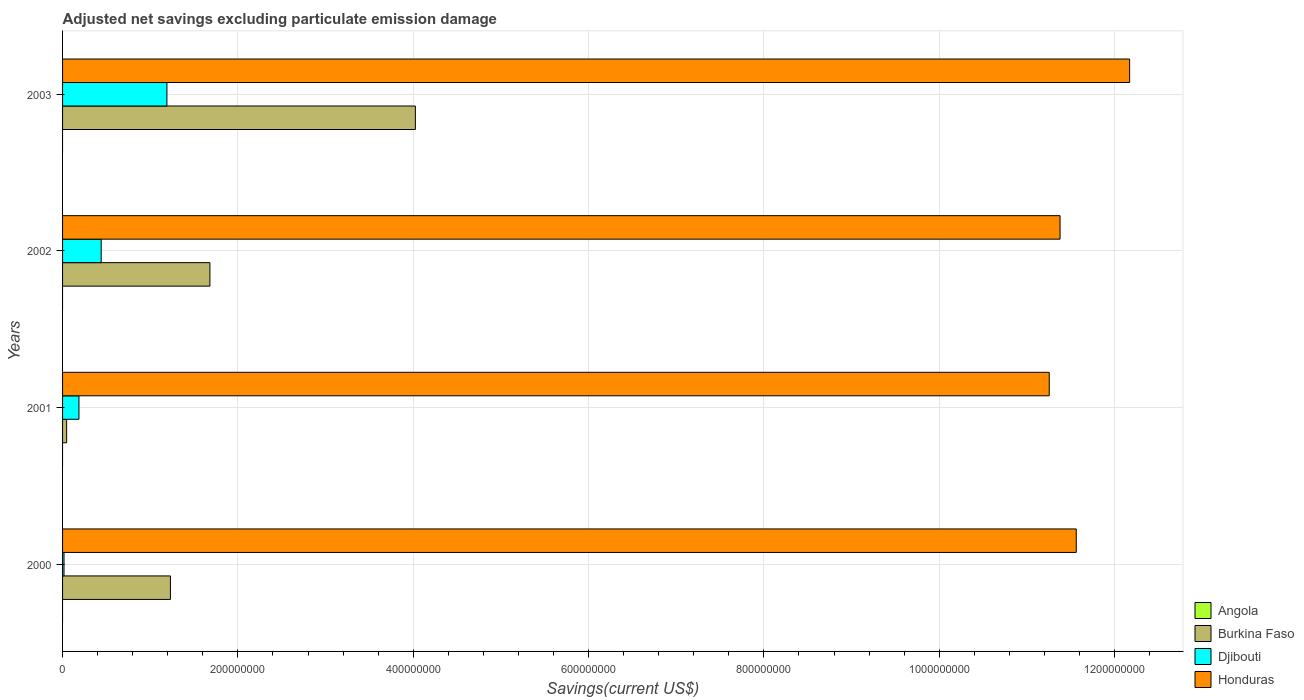How many bars are there on the 1st tick from the bottom?
Ensure brevity in your answer.  3. In how many cases, is the number of bars for a given year not equal to the number of legend labels?
Ensure brevity in your answer.  4. What is the adjusted net savings in Honduras in 2001?
Your answer should be very brief. 1.13e+09. Across all years, what is the maximum adjusted net savings in Burkina Faso?
Your answer should be compact. 4.02e+08. Across all years, what is the minimum adjusted net savings in Angola?
Provide a short and direct response. 0. In which year was the adjusted net savings in Burkina Faso maximum?
Offer a terse response. 2003. What is the total adjusted net savings in Honduras in the graph?
Give a very brief answer. 4.64e+09. What is the difference between the adjusted net savings in Honduras in 2000 and that in 2002?
Offer a terse response. 1.85e+07. What is the difference between the adjusted net savings in Angola in 2001 and the adjusted net savings in Djibouti in 2003?
Give a very brief answer. -1.19e+08. What is the average adjusted net savings in Burkina Faso per year?
Your answer should be compact. 1.75e+08. In the year 2000, what is the difference between the adjusted net savings in Burkina Faso and adjusted net savings in Djibouti?
Keep it short and to the point. 1.21e+08. What is the ratio of the adjusted net savings in Honduras in 2000 to that in 2003?
Give a very brief answer. 0.95. What is the difference between the highest and the second highest adjusted net savings in Djibouti?
Your answer should be very brief. 7.50e+07. What is the difference between the highest and the lowest adjusted net savings in Burkina Faso?
Your answer should be very brief. 3.98e+08. Is it the case that in every year, the sum of the adjusted net savings in Burkina Faso and adjusted net savings in Honduras is greater than the sum of adjusted net savings in Angola and adjusted net savings in Djibouti?
Provide a succinct answer. Yes. Is it the case that in every year, the sum of the adjusted net savings in Djibouti and adjusted net savings in Angola is greater than the adjusted net savings in Honduras?
Offer a very short reply. No. How many bars are there?
Keep it short and to the point. 12. Does the graph contain any zero values?
Offer a terse response. Yes. How many legend labels are there?
Provide a succinct answer. 4. How are the legend labels stacked?
Keep it short and to the point. Vertical. What is the title of the graph?
Offer a terse response. Adjusted net savings excluding particulate emission damage. Does "Swaziland" appear as one of the legend labels in the graph?
Keep it short and to the point. No. What is the label or title of the X-axis?
Offer a very short reply. Savings(current US$). What is the label or title of the Y-axis?
Provide a succinct answer. Years. What is the Savings(current US$) of Burkina Faso in 2000?
Provide a short and direct response. 1.23e+08. What is the Savings(current US$) of Djibouti in 2000?
Give a very brief answer. 1.66e+06. What is the Savings(current US$) of Honduras in 2000?
Provide a succinct answer. 1.16e+09. What is the Savings(current US$) in Burkina Faso in 2001?
Your answer should be very brief. 4.64e+06. What is the Savings(current US$) in Djibouti in 2001?
Provide a short and direct response. 1.87e+07. What is the Savings(current US$) in Honduras in 2001?
Ensure brevity in your answer.  1.13e+09. What is the Savings(current US$) in Burkina Faso in 2002?
Your answer should be very brief. 1.68e+08. What is the Savings(current US$) in Djibouti in 2002?
Give a very brief answer. 4.41e+07. What is the Savings(current US$) of Honduras in 2002?
Your answer should be very brief. 1.14e+09. What is the Savings(current US$) of Burkina Faso in 2003?
Keep it short and to the point. 4.02e+08. What is the Savings(current US$) in Djibouti in 2003?
Your answer should be compact. 1.19e+08. What is the Savings(current US$) in Honduras in 2003?
Ensure brevity in your answer.  1.22e+09. Across all years, what is the maximum Savings(current US$) of Burkina Faso?
Your response must be concise. 4.02e+08. Across all years, what is the maximum Savings(current US$) of Djibouti?
Make the answer very short. 1.19e+08. Across all years, what is the maximum Savings(current US$) in Honduras?
Offer a very short reply. 1.22e+09. Across all years, what is the minimum Savings(current US$) in Burkina Faso?
Provide a short and direct response. 4.64e+06. Across all years, what is the minimum Savings(current US$) in Djibouti?
Provide a short and direct response. 1.66e+06. Across all years, what is the minimum Savings(current US$) of Honduras?
Offer a very short reply. 1.13e+09. What is the total Savings(current US$) in Burkina Faso in the graph?
Offer a terse response. 6.98e+08. What is the total Savings(current US$) of Djibouti in the graph?
Your answer should be compact. 1.83e+08. What is the total Savings(current US$) of Honduras in the graph?
Your answer should be compact. 4.64e+09. What is the difference between the Savings(current US$) of Burkina Faso in 2000 and that in 2001?
Offer a terse response. 1.18e+08. What is the difference between the Savings(current US$) in Djibouti in 2000 and that in 2001?
Give a very brief answer. -1.70e+07. What is the difference between the Savings(current US$) in Honduras in 2000 and that in 2001?
Give a very brief answer. 3.08e+07. What is the difference between the Savings(current US$) of Burkina Faso in 2000 and that in 2002?
Your response must be concise. -4.50e+07. What is the difference between the Savings(current US$) in Djibouti in 2000 and that in 2002?
Your answer should be very brief. -4.24e+07. What is the difference between the Savings(current US$) of Honduras in 2000 and that in 2002?
Provide a short and direct response. 1.85e+07. What is the difference between the Savings(current US$) of Burkina Faso in 2000 and that in 2003?
Your response must be concise. -2.79e+08. What is the difference between the Savings(current US$) of Djibouti in 2000 and that in 2003?
Offer a terse response. -1.17e+08. What is the difference between the Savings(current US$) in Honduras in 2000 and that in 2003?
Provide a succinct answer. -6.09e+07. What is the difference between the Savings(current US$) in Burkina Faso in 2001 and that in 2002?
Provide a short and direct response. -1.63e+08. What is the difference between the Savings(current US$) of Djibouti in 2001 and that in 2002?
Keep it short and to the point. -2.54e+07. What is the difference between the Savings(current US$) in Honduras in 2001 and that in 2002?
Provide a short and direct response. -1.24e+07. What is the difference between the Savings(current US$) in Burkina Faso in 2001 and that in 2003?
Ensure brevity in your answer.  -3.98e+08. What is the difference between the Savings(current US$) in Djibouti in 2001 and that in 2003?
Provide a succinct answer. -1.00e+08. What is the difference between the Savings(current US$) of Honduras in 2001 and that in 2003?
Give a very brief answer. -9.17e+07. What is the difference between the Savings(current US$) in Burkina Faso in 2002 and that in 2003?
Offer a terse response. -2.34e+08. What is the difference between the Savings(current US$) in Djibouti in 2002 and that in 2003?
Give a very brief answer. -7.50e+07. What is the difference between the Savings(current US$) of Honduras in 2002 and that in 2003?
Offer a terse response. -7.94e+07. What is the difference between the Savings(current US$) in Burkina Faso in 2000 and the Savings(current US$) in Djibouti in 2001?
Ensure brevity in your answer.  1.04e+08. What is the difference between the Savings(current US$) of Burkina Faso in 2000 and the Savings(current US$) of Honduras in 2001?
Keep it short and to the point. -1.00e+09. What is the difference between the Savings(current US$) in Djibouti in 2000 and the Savings(current US$) in Honduras in 2001?
Provide a succinct answer. -1.12e+09. What is the difference between the Savings(current US$) in Burkina Faso in 2000 and the Savings(current US$) in Djibouti in 2002?
Your response must be concise. 7.90e+07. What is the difference between the Savings(current US$) in Burkina Faso in 2000 and the Savings(current US$) in Honduras in 2002?
Ensure brevity in your answer.  -1.01e+09. What is the difference between the Savings(current US$) of Djibouti in 2000 and the Savings(current US$) of Honduras in 2002?
Provide a succinct answer. -1.14e+09. What is the difference between the Savings(current US$) of Burkina Faso in 2000 and the Savings(current US$) of Djibouti in 2003?
Make the answer very short. 4.00e+06. What is the difference between the Savings(current US$) in Burkina Faso in 2000 and the Savings(current US$) in Honduras in 2003?
Offer a very short reply. -1.09e+09. What is the difference between the Savings(current US$) in Djibouti in 2000 and the Savings(current US$) in Honduras in 2003?
Make the answer very short. -1.22e+09. What is the difference between the Savings(current US$) of Burkina Faso in 2001 and the Savings(current US$) of Djibouti in 2002?
Offer a terse response. -3.94e+07. What is the difference between the Savings(current US$) of Burkina Faso in 2001 and the Savings(current US$) of Honduras in 2002?
Give a very brief answer. -1.13e+09. What is the difference between the Savings(current US$) in Djibouti in 2001 and the Savings(current US$) in Honduras in 2002?
Your answer should be very brief. -1.12e+09. What is the difference between the Savings(current US$) of Burkina Faso in 2001 and the Savings(current US$) of Djibouti in 2003?
Give a very brief answer. -1.14e+08. What is the difference between the Savings(current US$) in Burkina Faso in 2001 and the Savings(current US$) in Honduras in 2003?
Provide a succinct answer. -1.21e+09. What is the difference between the Savings(current US$) of Djibouti in 2001 and the Savings(current US$) of Honduras in 2003?
Offer a very short reply. -1.20e+09. What is the difference between the Savings(current US$) in Burkina Faso in 2002 and the Savings(current US$) in Djibouti in 2003?
Keep it short and to the point. 4.90e+07. What is the difference between the Savings(current US$) in Burkina Faso in 2002 and the Savings(current US$) in Honduras in 2003?
Provide a succinct answer. -1.05e+09. What is the difference between the Savings(current US$) of Djibouti in 2002 and the Savings(current US$) of Honduras in 2003?
Provide a succinct answer. -1.17e+09. What is the average Savings(current US$) of Angola per year?
Ensure brevity in your answer.  0. What is the average Savings(current US$) in Burkina Faso per year?
Make the answer very short. 1.75e+08. What is the average Savings(current US$) in Djibouti per year?
Provide a succinct answer. 4.59e+07. What is the average Savings(current US$) of Honduras per year?
Ensure brevity in your answer.  1.16e+09. In the year 2000, what is the difference between the Savings(current US$) of Burkina Faso and Savings(current US$) of Djibouti?
Keep it short and to the point. 1.21e+08. In the year 2000, what is the difference between the Savings(current US$) in Burkina Faso and Savings(current US$) in Honduras?
Ensure brevity in your answer.  -1.03e+09. In the year 2000, what is the difference between the Savings(current US$) of Djibouti and Savings(current US$) of Honduras?
Provide a short and direct response. -1.15e+09. In the year 2001, what is the difference between the Savings(current US$) in Burkina Faso and Savings(current US$) in Djibouti?
Ensure brevity in your answer.  -1.41e+07. In the year 2001, what is the difference between the Savings(current US$) of Burkina Faso and Savings(current US$) of Honduras?
Offer a very short reply. -1.12e+09. In the year 2001, what is the difference between the Savings(current US$) in Djibouti and Savings(current US$) in Honduras?
Ensure brevity in your answer.  -1.11e+09. In the year 2002, what is the difference between the Savings(current US$) of Burkina Faso and Savings(current US$) of Djibouti?
Ensure brevity in your answer.  1.24e+08. In the year 2002, what is the difference between the Savings(current US$) of Burkina Faso and Savings(current US$) of Honduras?
Your response must be concise. -9.70e+08. In the year 2002, what is the difference between the Savings(current US$) of Djibouti and Savings(current US$) of Honduras?
Offer a terse response. -1.09e+09. In the year 2003, what is the difference between the Savings(current US$) of Burkina Faso and Savings(current US$) of Djibouti?
Provide a succinct answer. 2.83e+08. In the year 2003, what is the difference between the Savings(current US$) of Burkina Faso and Savings(current US$) of Honduras?
Provide a succinct answer. -8.15e+08. In the year 2003, what is the difference between the Savings(current US$) of Djibouti and Savings(current US$) of Honduras?
Your answer should be very brief. -1.10e+09. What is the ratio of the Savings(current US$) of Burkina Faso in 2000 to that in 2001?
Your response must be concise. 26.49. What is the ratio of the Savings(current US$) in Djibouti in 2000 to that in 2001?
Your answer should be very brief. 0.09. What is the ratio of the Savings(current US$) in Honduras in 2000 to that in 2001?
Provide a short and direct response. 1.03. What is the ratio of the Savings(current US$) of Burkina Faso in 2000 to that in 2002?
Offer a terse response. 0.73. What is the ratio of the Savings(current US$) of Djibouti in 2000 to that in 2002?
Keep it short and to the point. 0.04. What is the ratio of the Savings(current US$) in Honduras in 2000 to that in 2002?
Offer a very short reply. 1.02. What is the ratio of the Savings(current US$) of Burkina Faso in 2000 to that in 2003?
Your answer should be compact. 0.31. What is the ratio of the Savings(current US$) of Djibouti in 2000 to that in 2003?
Your response must be concise. 0.01. What is the ratio of the Savings(current US$) of Burkina Faso in 2001 to that in 2002?
Your answer should be compact. 0.03. What is the ratio of the Savings(current US$) in Djibouti in 2001 to that in 2002?
Your answer should be compact. 0.42. What is the ratio of the Savings(current US$) in Honduras in 2001 to that in 2002?
Keep it short and to the point. 0.99. What is the ratio of the Savings(current US$) in Burkina Faso in 2001 to that in 2003?
Keep it short and to the point. 0.01. What is the ratio of the Savings(current US$) of Djibouti in 2001 to that in 2003?
Your answer should be compact. 0.16. What is the ratio of the Savings(current US$) in Honduras in 2001 to that in 2003?
Provide a succinct answer. 0.92. What is the ratio of the Savings(current US$) in Burkina Faso in 2002 to that in 2003?
Your answer should be very brief. 0.42. What is the ratio of the Savings(current US$) of Djibouti in 2002 to that in 2003?
Provide a succinct answer. 0.37. What is the ratio of the Savings(current US$) in Honduras in 2002 to that in 2003?
Offer a terse response. 0.93. What is the difference between the highest and the second highest Savings(current US$) of Burkina Faso?
Provide a succinct answer. 2.34e+08. What is the difference between the highest and the second highest Savings(current US$) of Djibouti?
Your answer should be compact. 7.50e+07. What is the difference between the highest and the second highest Savings(current US$) in Honduras?
Make the answer very short. 6.09e+07. What is the difference between the highest and the lowest Savings(current US$) of Burkina Faso?
Your answer should be very brief. 3.98e+08. What is the difference between the highest and the lowest Savings(current US$) in Djibouti?
Your answer should be very brief. 1.17e+08. What is the difference between the highest and the lowest Savings(current US$) in Honduras?
Provide a succinct answer. 9.17e+07. 